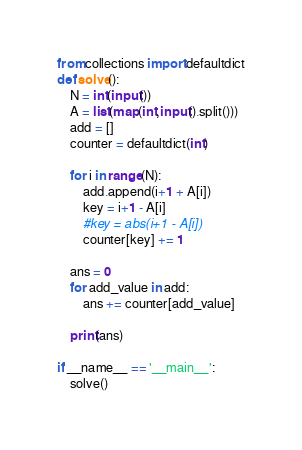Convert code to text. <code><loc_0><loc_0><loc_500><loc_500><_Python_>from collections import defaultdict
def solve():
    N = int(input())
    A = list(map(int,input().split()))
    add = []
    counter = defaultdict(int)
    
    for i in range(N):
        add.append(i+1 + A[i])
        key = i+1 - A[i]
        #key = abs(i+1 - A[i])
        counter[key] += 1
    
    ans = 0
    for add_value in add:
        ans += counter[add_value]
    
    print(ans)

if __name__ == '__main__':
    solve()</code> 